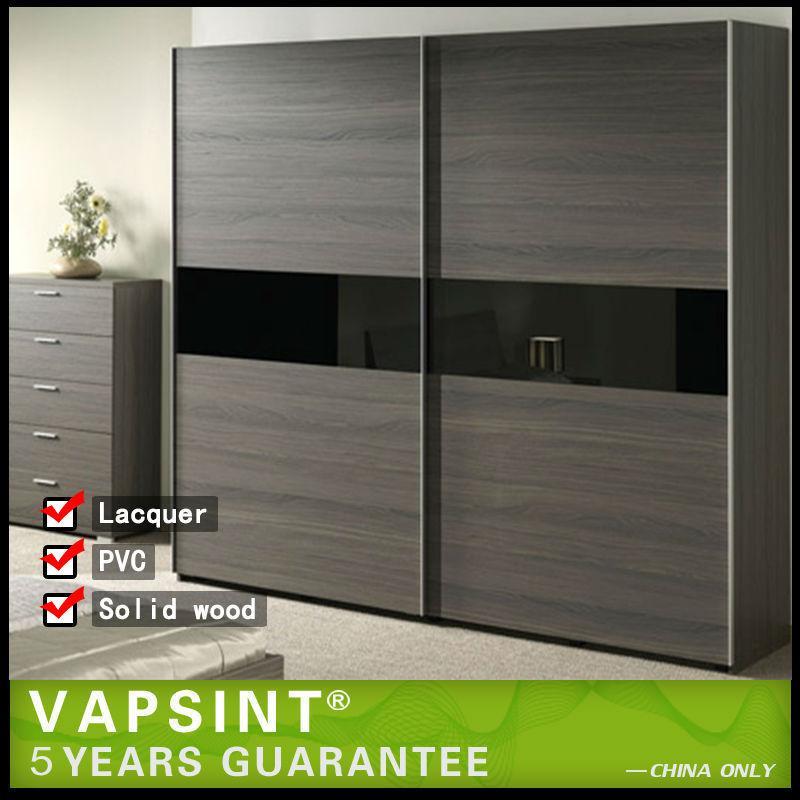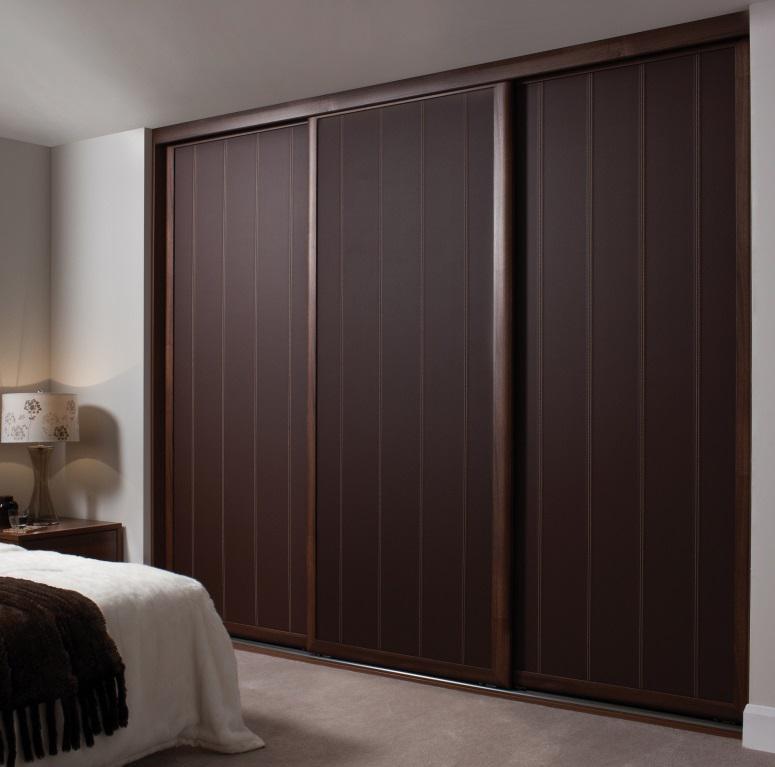The first image is the image on the left, the second image is the image on the right. Evaluate the accuracy of this statement regarding the images: "In one of the images there are clothes visible inside the partially open closet.". Is it true? Answer yes or no. No. 